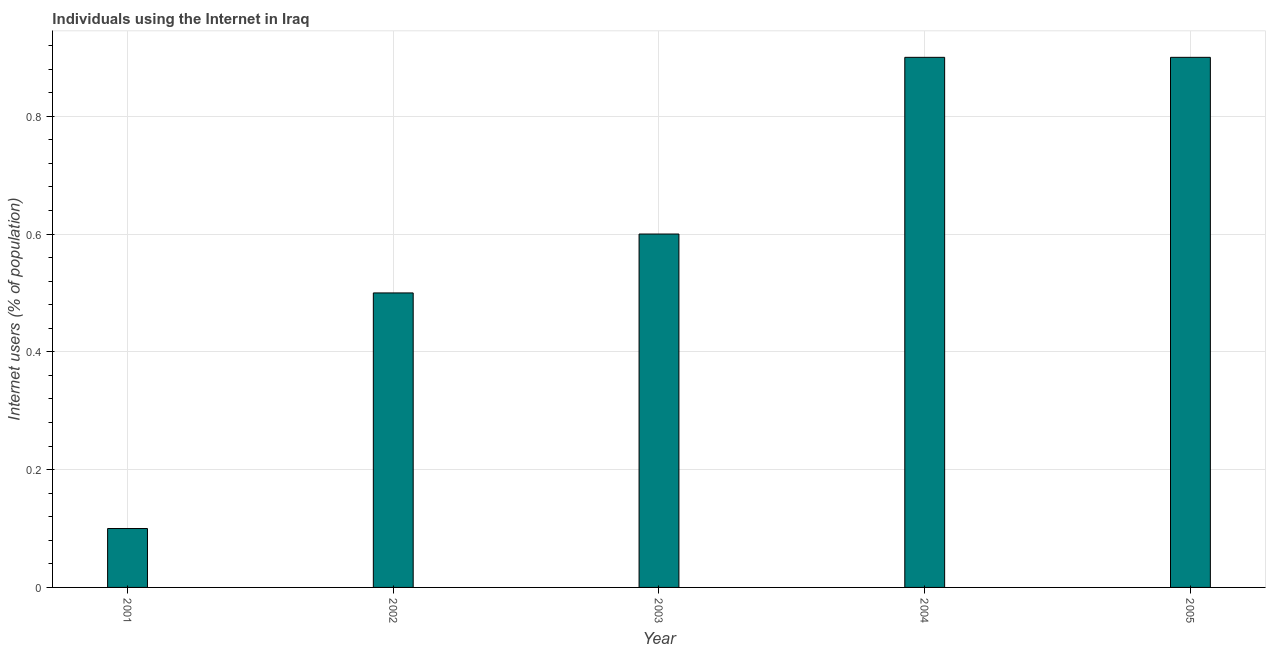Does the graph contain grids?
Ensure brevity in your answer.  Yes. What is the title of the graph?
Your response must be concise. Individuals using the Internet in Iraq. What is the label or title of the Y-axis?
Provide a succinct answer. Internet users (% of population). What is the number of internet users in 2001?
Keep it short and to the point. 0.1. Across all years, what is the maximum number of internet users?
Keep it short and to the point. 0.9. In which year was the number of internet users minimum?
Provide a short and direct response. 2001. What is the sum of the number of internet users?
Offer a very short reply. 3. What is the difference between the number of internet users in 2001 and 2005?
Offer a very short reply. -0.8. What is the median number of internet users?
Offer a terse response. 0.6. In how many years, is the number of internet users greater than 0.24 %?
Offer a very short reply. 4. Do a majority of the years between 2004 and 2005 (inclusive) have number of internet users greater than 0.08 %?
Make the answer very short. Yes. What is the ratio of the number of internet users in 2001 to that in 2005?
Provide a short and direct response. 0.11. Is the difference between the number of internet users in 2002 and 2004 greater than the difference between any two years?
Ensure brevity in your answer.  No. What is the difference between the highest and the lowest number of internet users?
Offer a terse response. 0.8. In how many years, is the number of internet users greater than the average number of internet users taken over all years?
Provide a short and direct response. 2. How many years are there in the graph?
Your response must be concise. 5. Are the values on the major ticks of Y-axis written in scientific E-notation?
Provide a short and direct response. No. What is the Internet users (% of population) of 2005?
Provide a short and direct response. 0.9. What is the difference between the Internet users (% of population) in 2001 and 2002?
Your response must be concise. -0.4. What is the difference between the Internet users (% of population) in 2001 and 2003?
Provide a succinct answer. -0.5. What is the difference between the Internet users (% of population) in 2001 and 2004?
Give a very brief answer. -0.8. What is the difference between the Internet users (% of population) in 2001 and 2005?
Your answer should be compact. -0.8. What is the difference between the Internet users (% of population) in 2003 and 2005?
Make the answer very short. -0.3. What is the ratio of the Internet users (% of population) in 2001 to that in 2003?
Offer a terse response. 0.17. What is the ratio of the Internet users (% of population) in 2001 to that in 2004?
Your answer should be very brief. 0.11. What is the ratio of the Internet users (% of population) in 2001 to that in 2005?
Offer a very short reply. 0.11. What is the ratio of the Internet users (% of population) in 2002 to that in 2003?
Provide a short and direct response. 0.83. What is the ratio of the Internet users (% of population) in 2002 to that in 2004?
Keep it short and to the point. 0.56. What is the ratio of the Internet users (% of population) in 2002 to that in 2005?
Provide a short and direct response. 0.56. What is the ratio of the Internet users (% of population) in 2003 to that in 2004?
Provide a short and direct response. 0.67. What is the ratio of the Internet users (% of population) in 2003 to that in 2005?
Offer a very short reply. 0.67. 